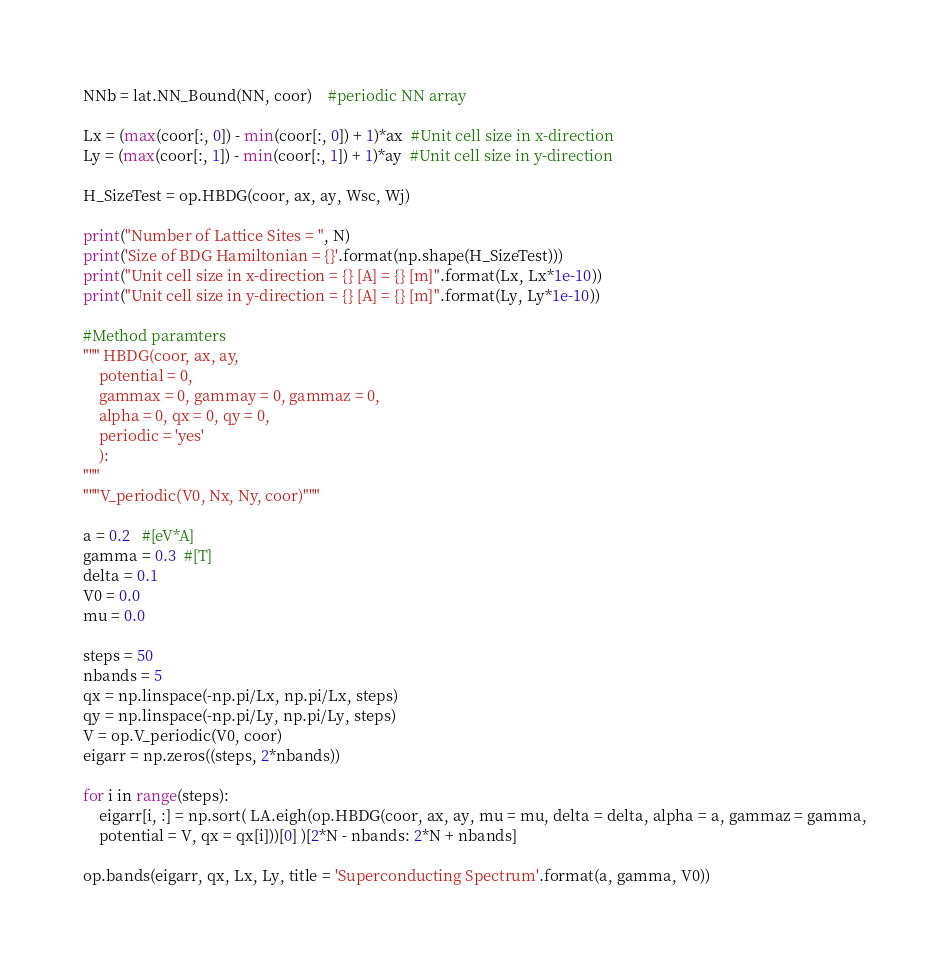Convert code to text. <code><loc_0><loc_0><loc_500><loc_500><_Python_>NNb = lat.NN_Bound(NN, coor)    #periodic NN array

Lx = (max(coor[:, 0]) - min(coor[:, 0]) + 1)*ax  #Unit cell size in x-direction
Ly = (max(coor[:, 1]) - min(coor[:, 1]) + 1)*ay  #Unit cell size in y-direction

H_SizeTest = op.HBDG(coor, ax, ay, Wsc, Wj)

print("Number of Lattice Sites = ", N)
print('Size of BDG Hamiltonian = {}'.format(np.shape(H_SizeTest)))
print("Unit cell size in x-direction = {} [A] = {} [m]".format(Lx, Lx*1e-10))
print("Unit cell size in y-direction = {} [A] = {} [m]".format(Ly, Ly*1e-10))

#Method paramters
""" HBDG(coor, ax, ay,
    potential = 0,
    gammax = 0, gammay = 0, gammaz = 0,
    alpha = 0, qx = 0, qy = 0,
    periodic = 'yes'
    ):
"""
"""V_periodic(V0, Nx, Ny, coor)"""

a = 0.2   #[eV*A]
gamma = 0.3  #[T]
delta = 0.1
V0 = 0.0
mu = 0.0

steps = 50
nbands = 5
qx = np.linspace(-np.pi/Lx, np.pi/Lx, steps)
qy = np.linspace(-np.pi/Ly, np.pi/Ly, steps)
V = op.V_periodic(V0, coor)
eigarr = np.zeros((steps, 2*nbands))

for i in range(steps):
    eigarr[i, :] = np.sort( LA.eigh(op.HBDG(coor, ax, ay, mu = mu, delta = delta, alpha = a, gammaz = gamma,
    potential = V, qx = qx[i]))[0] )[2*N - nbands: 2*N + nbands]

op.bands(eigarr, qx, Lx, Ly, title = 'Superconducting Spectrum'.format(a, gamma, V0))
</code> 